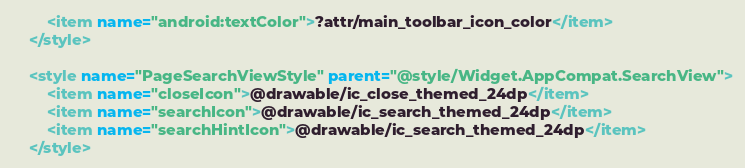Convert code to text. <code><loc_0><loc_0><loc_500><loc_500><_XML_>        <item name="android:textColor">?attr/main_toolbar_icon_color</item>
    </style>

    <style name="PageSearchViewStyle" parent="@style/Widget.AppCompat.SearchView">
        <item name="closeIcon">@drawable/ic_close_themed_24dp</item>
        <item name="searchIcon">@drawable/ic_search_themed_24dp</item>
        <item name="searchHintIcon">@drawable/ic_search_themed_24dp</item>
    </style>
</code> 